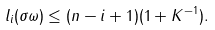<formula> <loc_0><loc_0><loc_500><loc_500>l _ { i } ( \sigma \omega ) \leq ( n - i + 1 ) ( 1 + K ^ { - 1 } ) .</formula> 